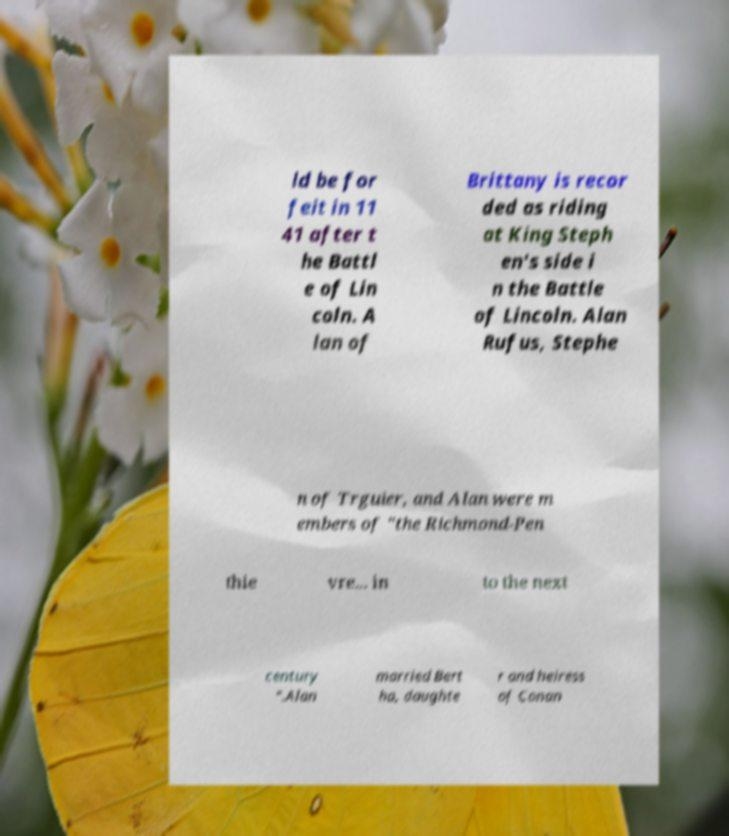What messages or text are displayed in this image? I need them in a readable, typed format. ld be for feit in 11 41 after t he Battl e of Lin coln. A lan of Brittany is recor ded as riding at King Steph en's side i n the Battle of Lincoln. Alan Rufus, Stephe n of Trguier, and Alan were m embers of "the Richmond-Pen thie vre... in to the next century ".Alan married Bert ha, daughte r and heiress of Conan 